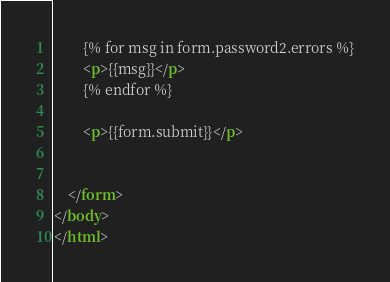<code> <loc_0><loc_0><loc_500><loc_500><_HTML_>        {% for msg in form.password2.errors %}
        <p>{{msg}}</p>
        {% endfor %}

        <p>{{form.submit}}</p>


    </form>
</body>
</html></code> 